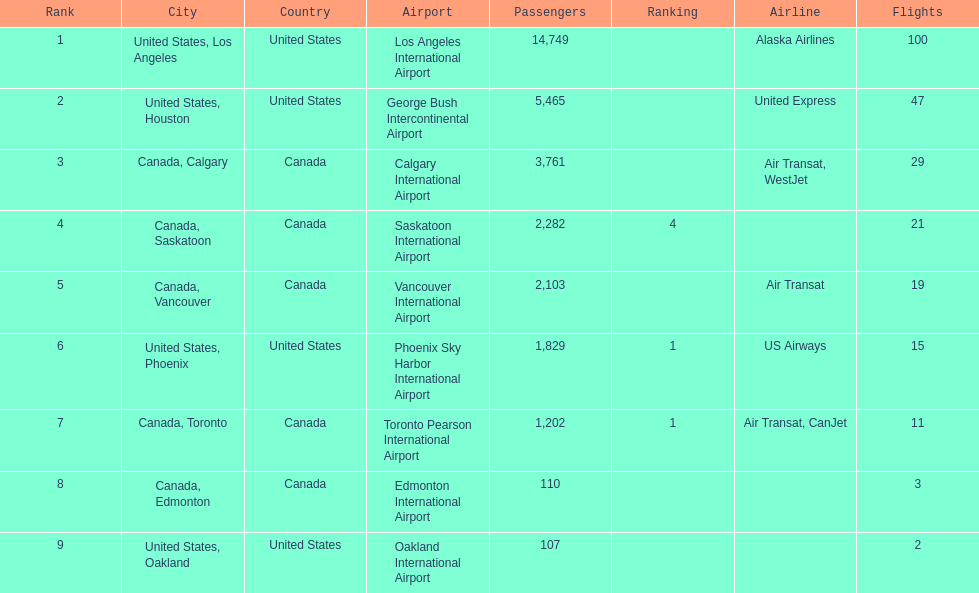The difference in passengers between los angeles and toronto 13,547. Give me the full table as a dictionary. {'header': ['Rank', 'City', 'Country', 'Airport', 'Passengers', 'Ranking', 'Airline', 'Flights'], 'rows': [['1', 'United States, Los Angeles', 'United States', 'Los Angeles International Airport', '14,749', '', 'Alaska Airlines', '100'], ['2', 'United States, Houston', 'United States', 'George Bush Intercontinental Airport', '5,465', '', 'United Express', '47'], ['3', 'Canada, Calgary', 'Canada', 'Calgary International Airport', '3,761', '', 'Air Transat, WestJet', '29'], ['4', 'Canada, Saskatoon', 'Canada', 'Saskatoon International Airport', '2,282', '4', '', '21'], ['5', 'Canada, Vancouver', 'Canada', 'Vancouver International Airport', '2,103', '', 'Air Transat', '19'], ['6', 'United States, Phoenix', 'United States', 'Phoenix Sky Harbor International Airport', '1,829', '1', 'US Airways', '15'], ['7', 'Canada, Toronto', 'Canada', 'Toronto Pearson International Airport', '1,202', '1', 'Air Transat, CanJet', '11'], ['8', 'Canada, Edmonton', 'Canada', 'Edmonton International Airport', '110', '', '', '3'], ['9', 'United States, Oakland', 'United States', 'Oakland International Airport', '107', '', '', '2']]} 